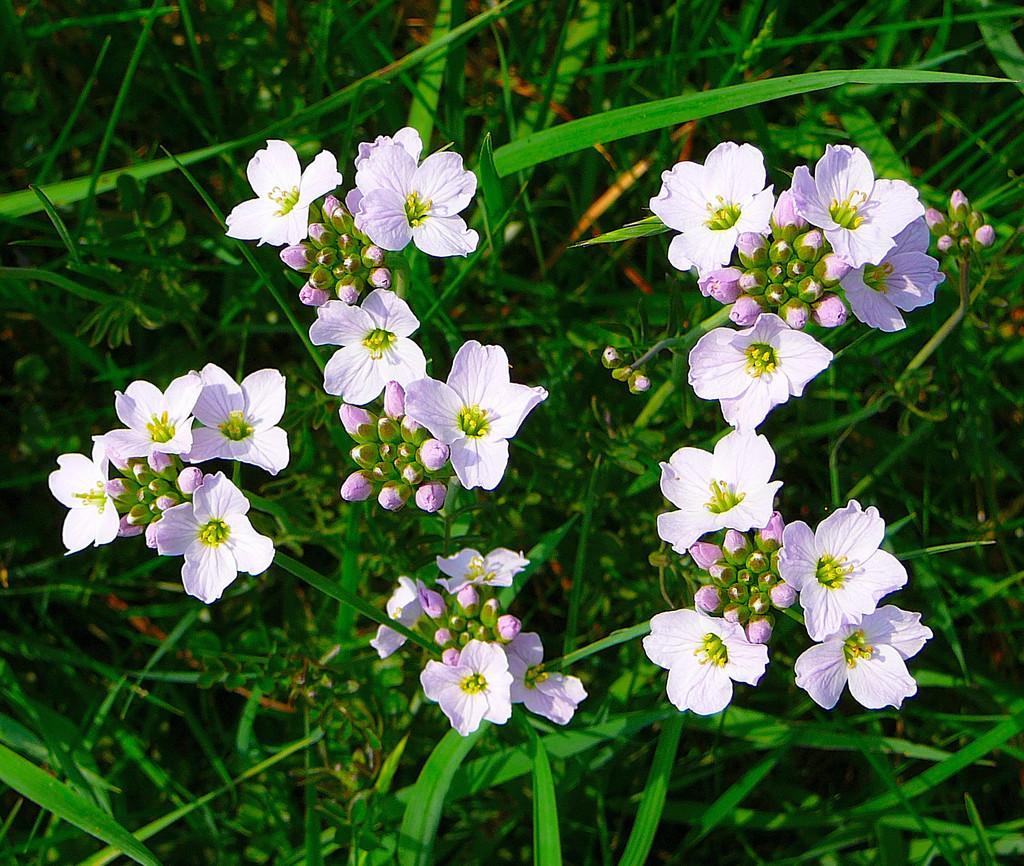Please provide a concise description of this image. In this picture I can observe flowers. In the background there are plants on the ground which are in green color. 